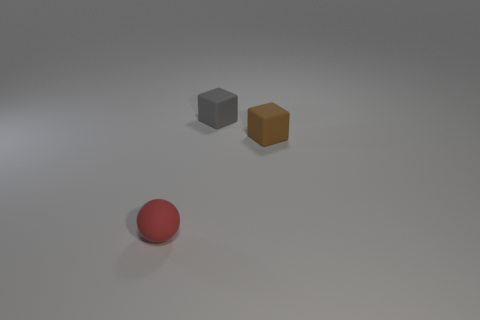Add 1 purple cylinders. How many objects exist? 4 Subtract all cubes. How many objects are left? 1 Add 1 gray matte objects. How many gray matte objects are left? 2 Add 1 shiny blocks. How many shiny blocks exist? 1 Subtract 0 red cylinders. How many objects are left? 3 Subtract all red metallic cylinders. Subtract all small gray rubber cubes. How many objects are left? 2 